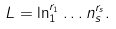Convert formula to latex. <formula><loc_0><loc_0><loc_500><loc_500>L = \ln _ { 1 } ^ { r _ { 1 } } \dots n _ { s } ^ { r _ { s } } .</formula> 